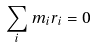<formula> <loc_0><loc_0><loc_500><loc_500>\sum _ { i } m _ { i } r _ { i } = 0</formula> 